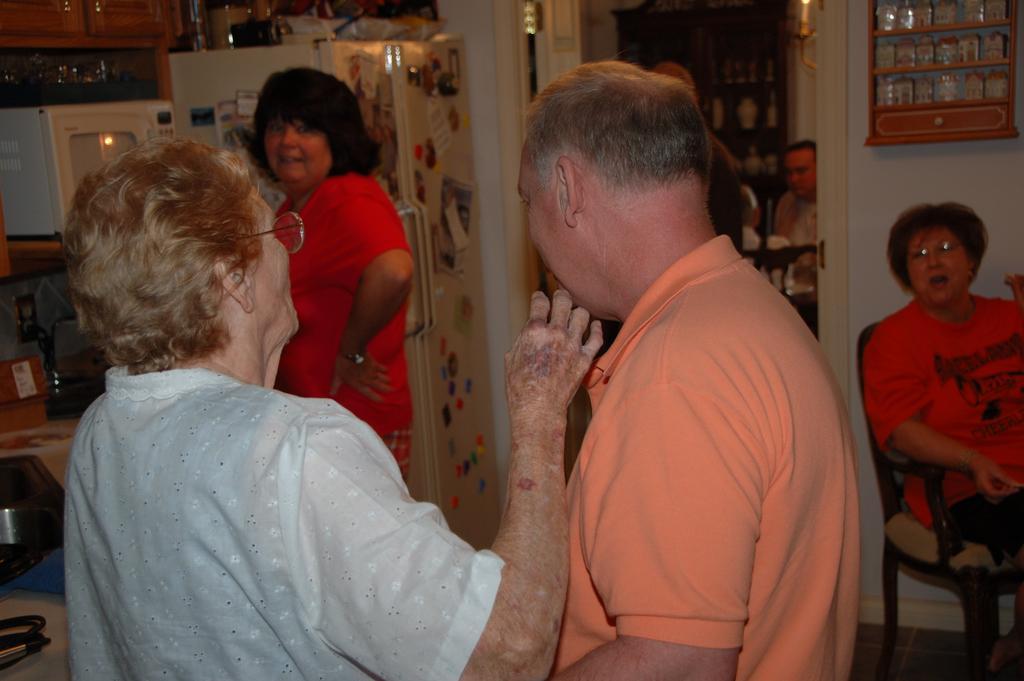Please provide a concise description of this image. In the center we can see three persons were standing. On the right there is one woman sitting on the chair. In the background there is a fridge,cupboard,wall,table,chair and two persons were sitting on the chair. 